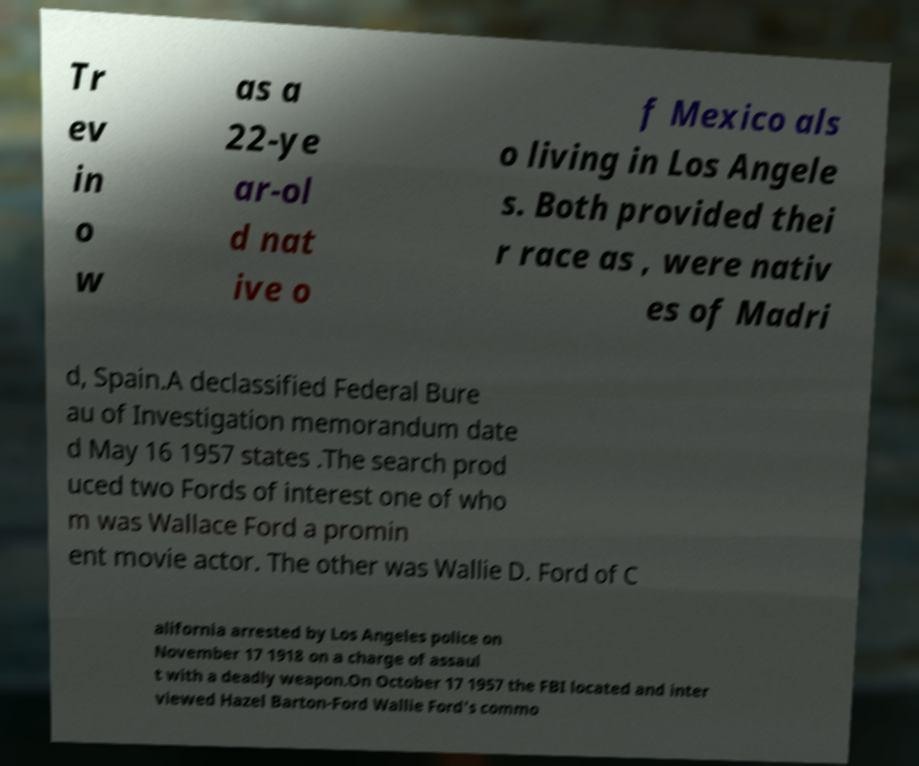Can you accurately transcribe the text from the provided image for me? Tr ev in o w as a 22-ye ar-ol d nat ive o f Mexico als o living in Los Angele s. Both provided thei r race as , were nativ es of Madri d, Spain.A declassified Federal Bure au of Investigation memorandum date d May 16 1957 states .The search prod uced two Fords of interest one of who m was Wallace Ford a promin ent movie actor. The other was Wallie D. Ford of C alifornia arrested by Los Angeles police on November 17 1918 on a charge of assaul t with a deadly weapon.On October 17 1957 the FBI located and inter viewed Hazel Barton-Ford Wallie Ford's commo 